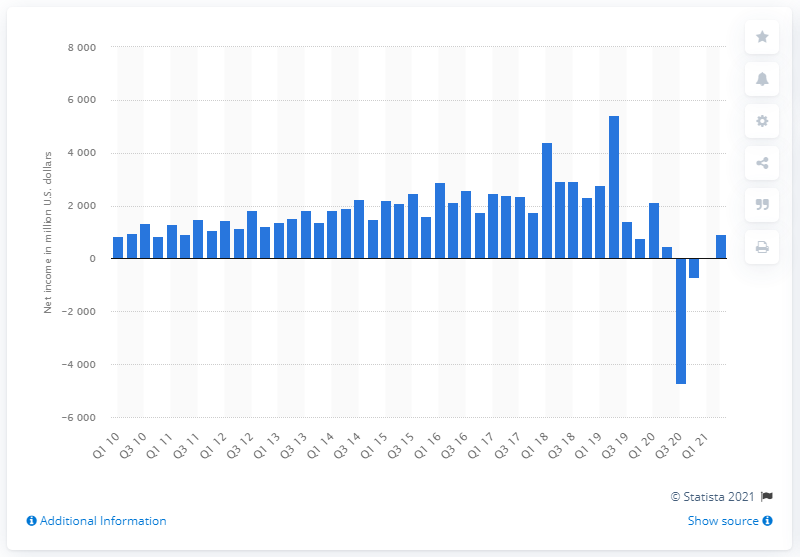Indicate a few pertinent items in this graphic. The net profit of the Walt Disney Company in the second quarter of 2021 was 912 million dollars. 